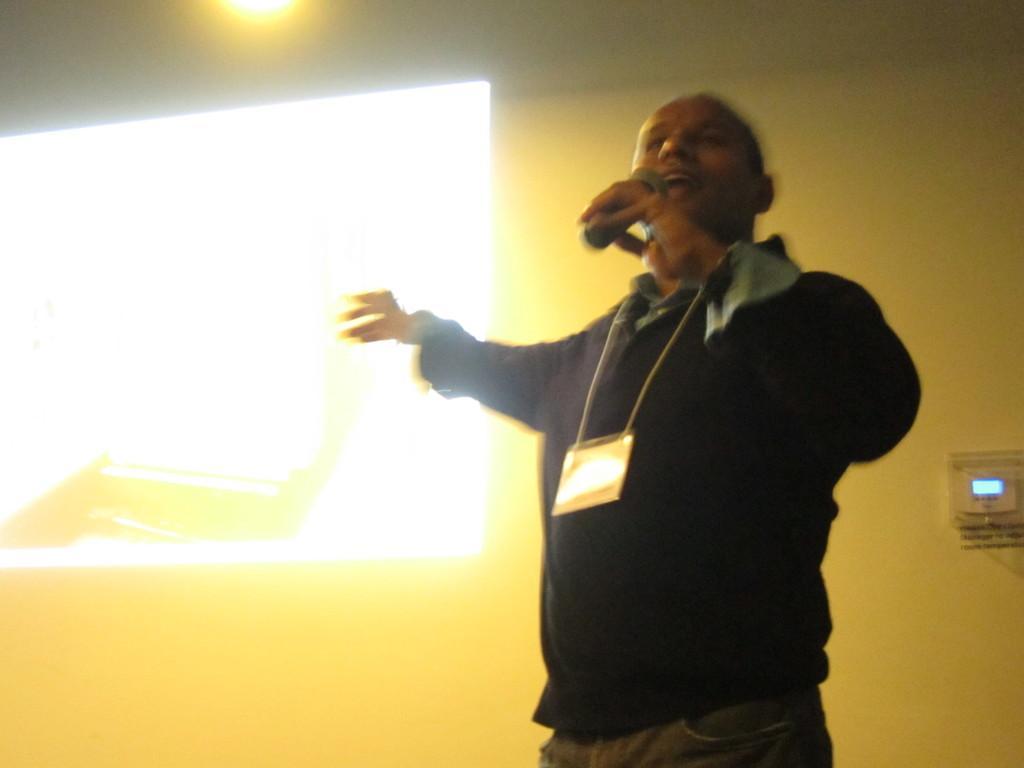Can you describe this image briefly? In this image i can see a man standing and holding a microphone in his hand. In the background i can see a wall and a screen. 